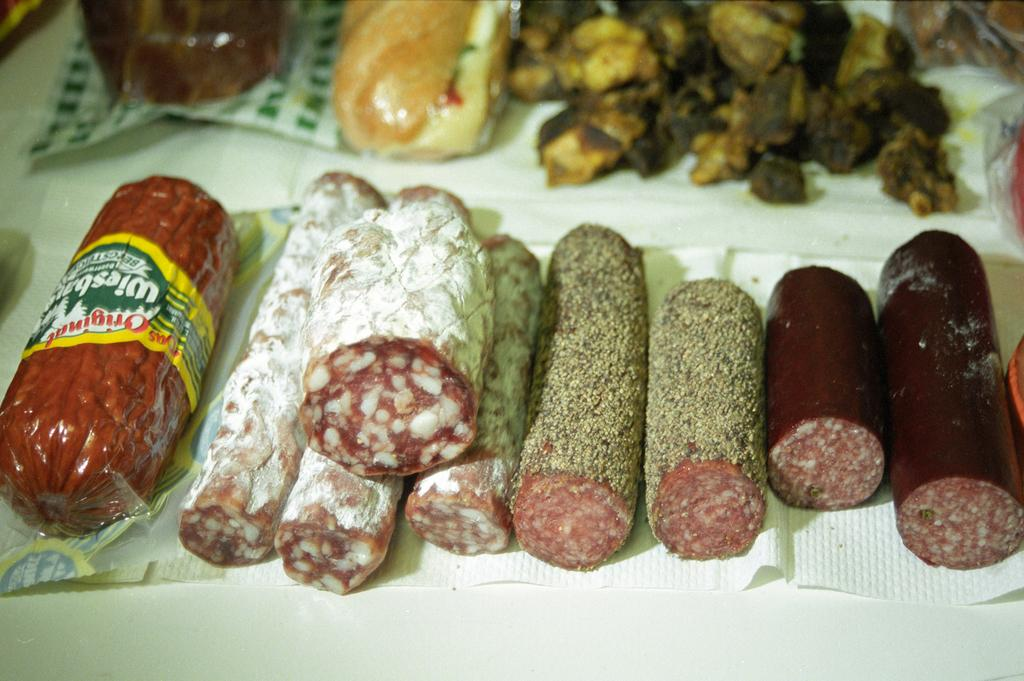What is the main piece of furniture in the image? There is a table in the image. What is placed on the table? The table has many food items on it. Are there any additional items on the table besides food? Yes, there are tissue papers on the table. How many pigs can be seen eating the food on the table in the image? There are no pigs present in the image; it only shows a table with food items and tissue papers. 